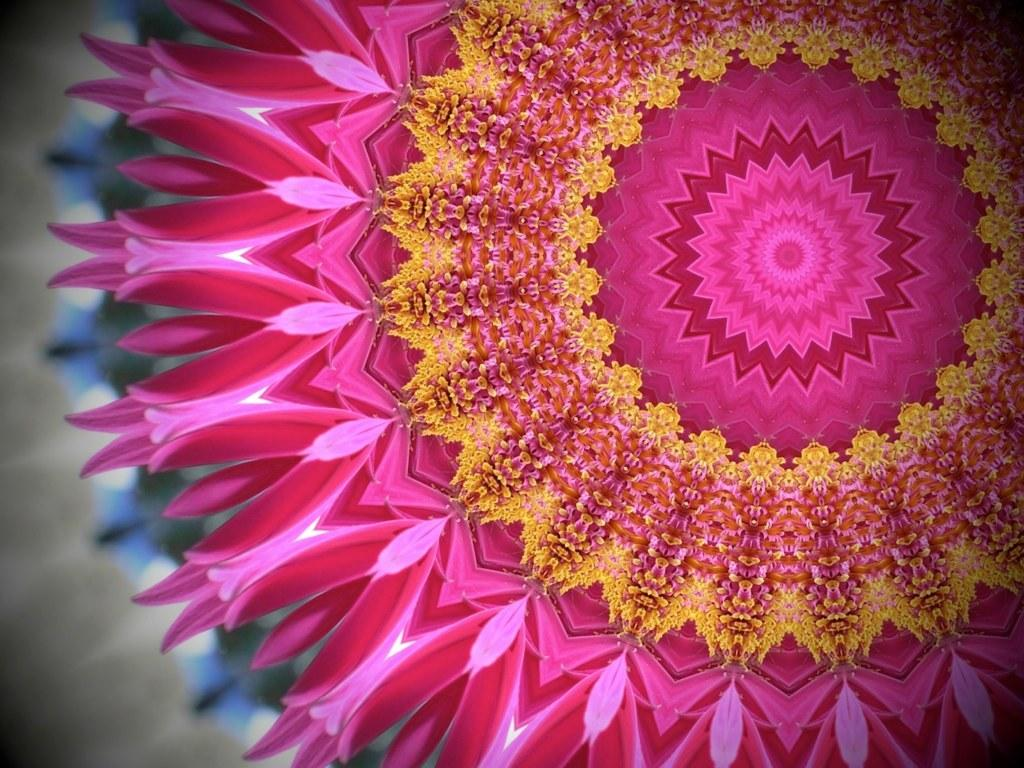What is the main subject in the image? There is a painting in the image. What grade did the story about the stocking receive in the image? There is no story or stocking present in the image; it only features a painting. 